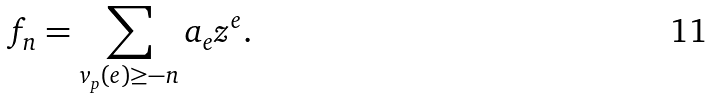<formula> <loc_0><loc_0><loc_500><loc_500>f _ { n } = \sum _ { v _ { p } ( e ) \geq - n } a _ { e } z ^ { e } .</formula> 